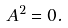<formula> <loc_0><loc_0><loc_500><loc_500>A ^ { 2 } = 0 .</formula> 